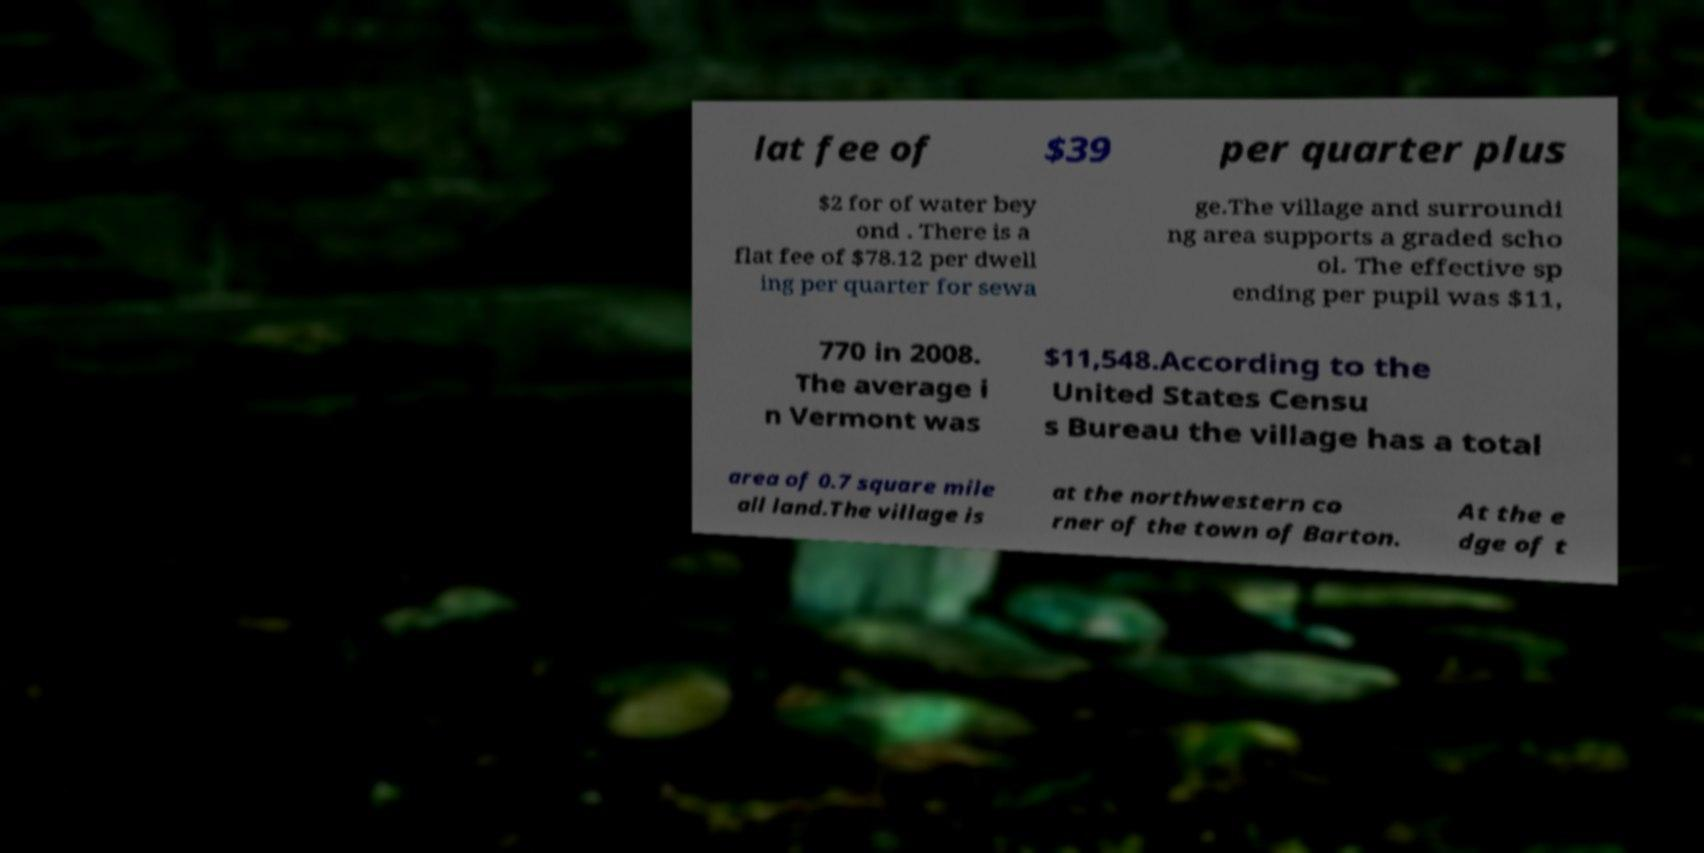I need the written content from this picture converted into text. Can you do that? lat fee of $39 per quarter plus $2 for of water bey ond . There is a flat fee of $78.12 per dwell ing per quarter for sewa ge.The village and surroundi ng area supports a graded scho ol. The effective sp ending per pupil was $11, 770 in 2008. The average i n Vermont was $11,548.According to the United States Censu s Bureau the village has a total area of 0.7 square mile all land.The village is at the northwestern co rner of the town of Barton. At the e dge of t 